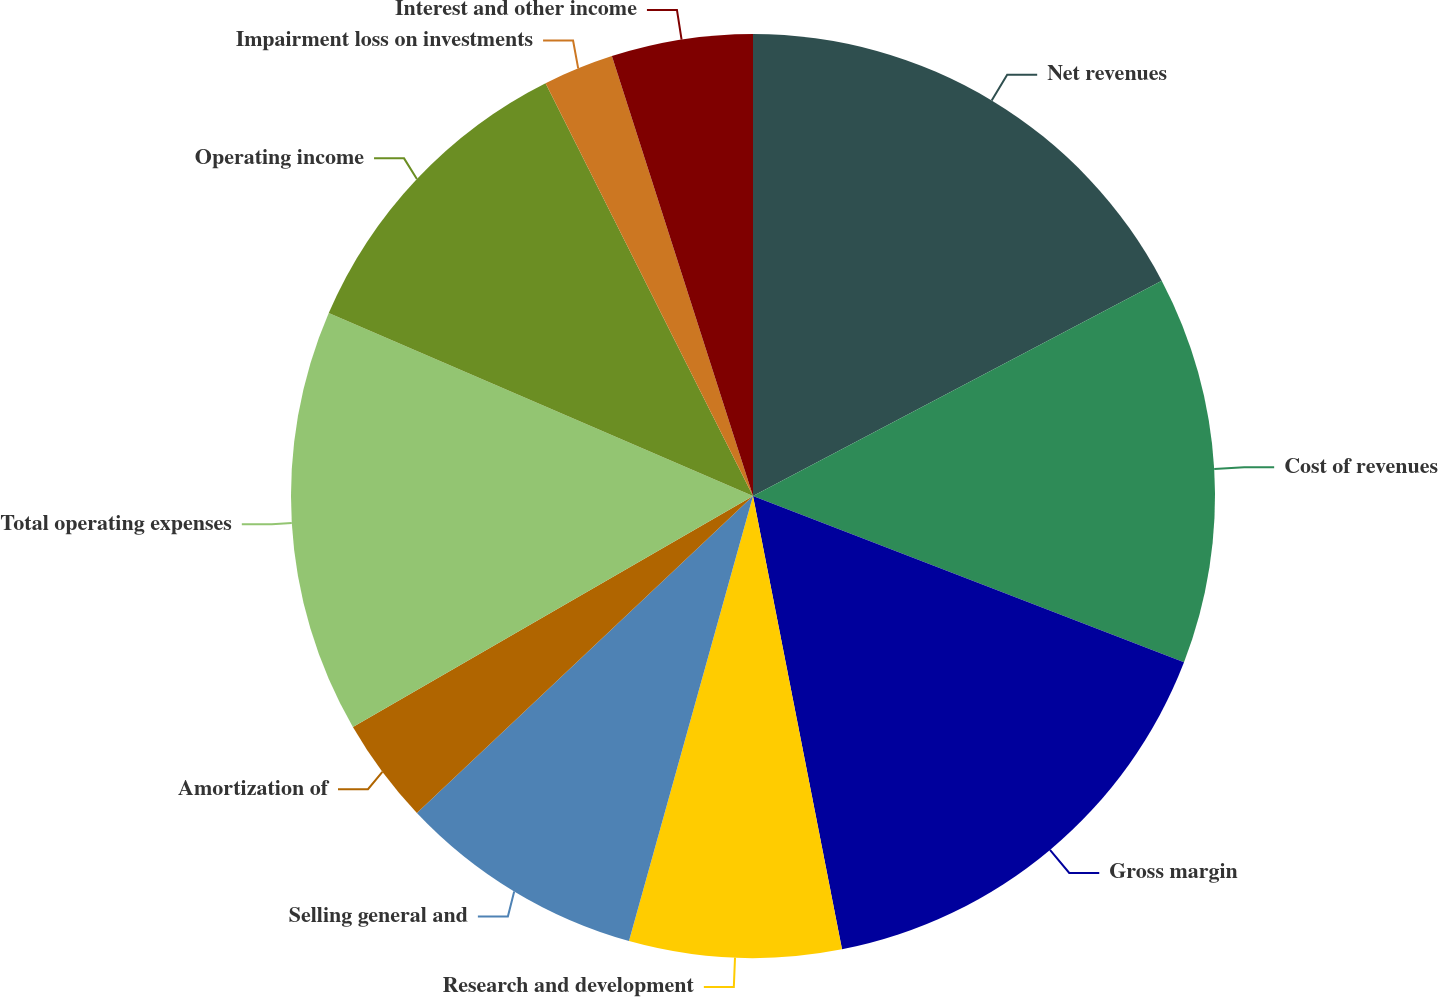Convert chart to OTSL. <chart><loc_0><loc_0><loc_500><loc_500><pie_chart><fcel>Net revenues<fcel>Cost of revenues<fcel>Gross margin<fcel>Research and development<fcel>Selling general and<fcel>Amortization of<fcel>Total operating expenses<fcel>Operating income<fcel>Impairment loss on investments<fcel>Interest and other income<nl><fcel>17.28%<fcel>13.58%<fcel>16.05%<fcel>7.41%<fcel>8.64%<fcel>3.7%<fcel>14.81%<fcel>11.11%<fcel>2.47%<fcel>4.94%<nl></chart> 